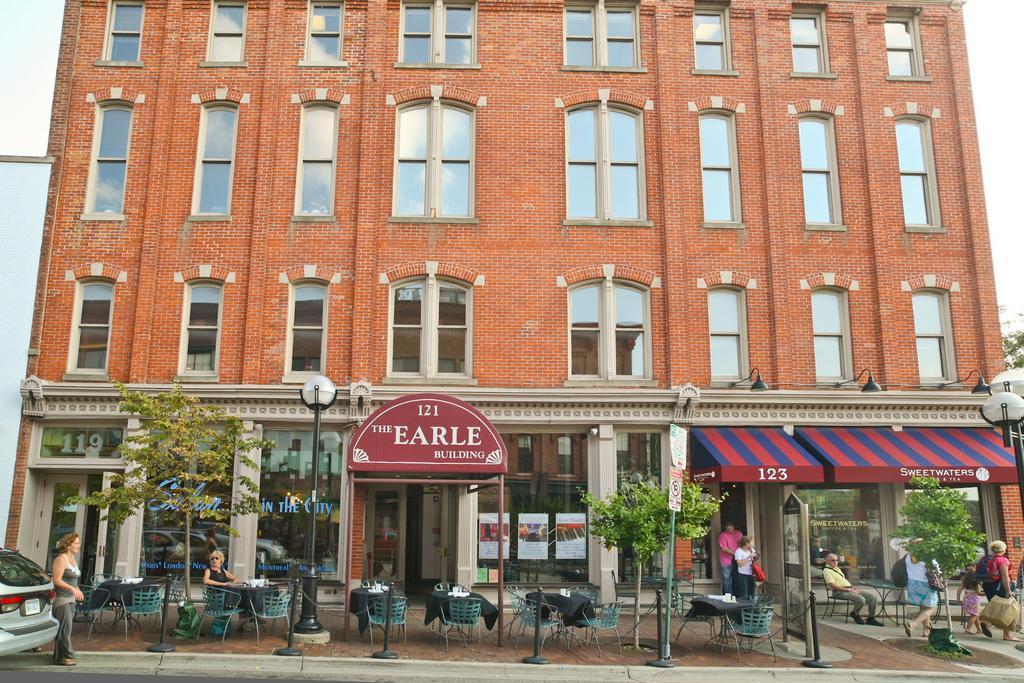Could you give a brief overview of what you see in this image? At the bottom we can see chairs at the tables on the floor and there are objects on the tables and we can see few persons are sitting on the chairs and few persons are standing and walking on the floor. We can see trees, light poles, boards on the poles and a car on the left side. We can see a building, windows and in the background we can see clouds in the sky. 